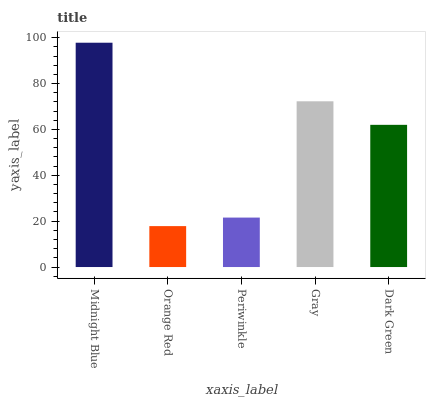Is Orange Red the minimum?
Answer yes or no. Yes. Is Midnight Blue the maximum?
Answer yes or no. Yes. Is Periwinkle the minimum?
Answer yes or no. No. Is Periwinkle the maximum?
Answer yes or no. No. Is Periwinkle greater than Orange Red?
Answer yes or no. Yes. Is Orange Red less than Periwinkle?
Answer yes or no. Yes. Is Orange Red greater than Periwinkle?
Answer yes or no. No. Is Periwinkle less than Orange Red?
Answer yes or no. No. Is Dark Green the high median?
Answer yes or no. Yes. Is Dark Green the low median?
Answer yes or no. Yes. Is Midnight Blue the high median?
Answer yes or no. No. Is Gray the low median?
Answer yes or no. No. 